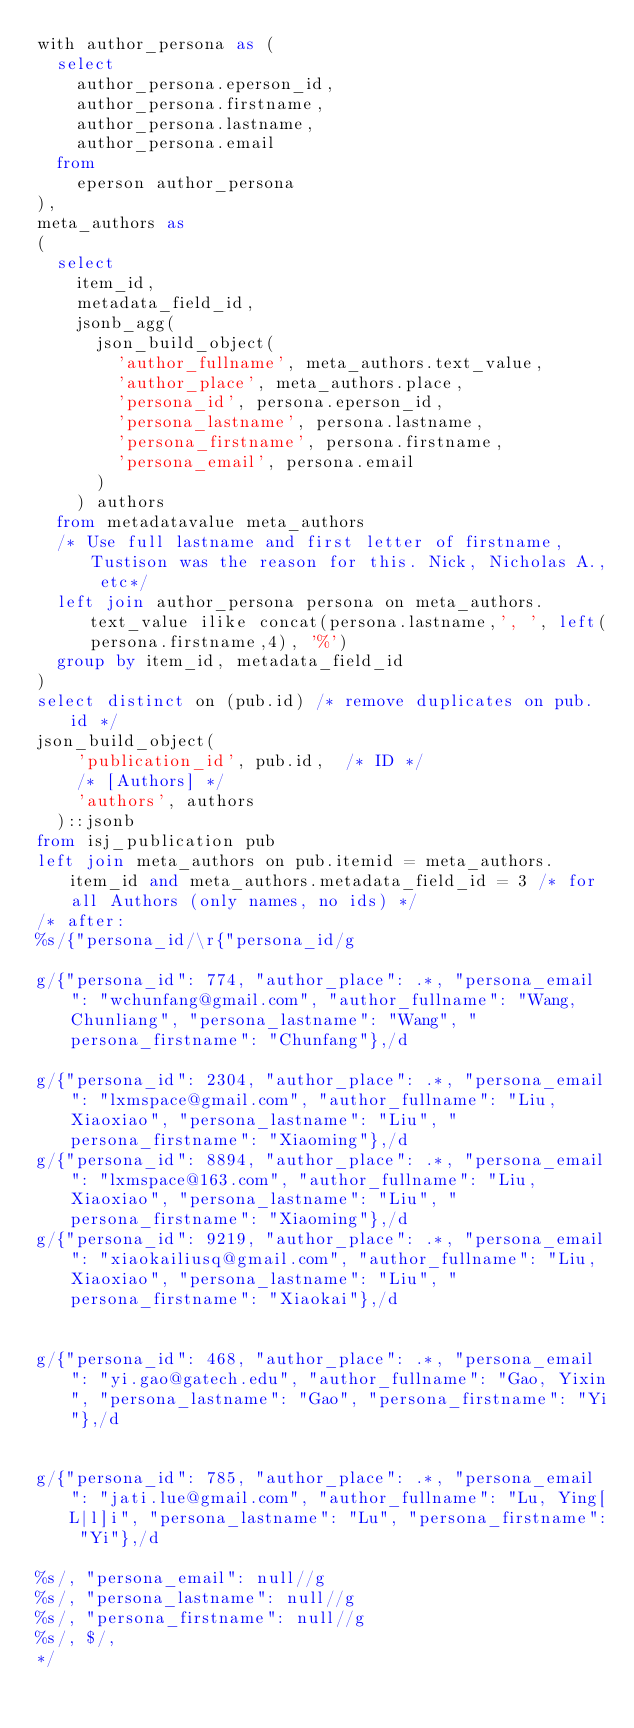Convert code to text. <code><loc_0><loc_0><loc_500><loc_500><_SQL_>with author_persona as (
  select
    author_persona.eperson_id,
    author_persona.firstname,
    author_persona.lastname,
    author_persona.email
  from
    eperson author_persona
),
meta_authors as
(
  select
	item_id,
	metadata_field_id,
	jsonb_agg(
	  json_build_object(
		'author_fullname', meta_authors.text_value,
		'author_place', meta_authors.place,
		'persona_id', persona.eperson_id,
		'persona_lastname', persona.lastname,
		'persona_firstname', persona.firstname,
		'persona_email', persona.email
	  )
	) authors
  from metadatavalue meta_authors
  /* Use full lastname and first letter of firstname, Tustison was the reason for this. Nick, Nicholas A., etc*/
  left join author_persona persona on meta_authors.text_value ilike concat(persona.lastname,', ', left(persona.firstname,4), '%')
  group by item_id, metadata_field_id
)
select distinct on (pub.id) /* remove duplicates on pub.id */
json_build_object(
	'publication_id', pub.id,  /* ID */
	/* [Authors] */
	'authors', authors
  )::jsonb
from isj_publication pub
left join meta_authors on pub.itemid = meta_authors.item_id and meta_authors.metadata_field_id = 3 /* for all Authors (only names, no ids) */
/* after:
%s/{"persona_id/\r{"persona_id/g

g/{"persona_id": 774, "author_place": .*, "persona_email": "wchunfang@gmail.com", "author_fullname": "Wang, Chunliang", "persona_lastname": "Wang", "persona_firstname": "Chunfang"},/d

g/{"persona_id": 2304, "author_place": .*, "persona_email": "lxmspace@gmail.com", "author_fullname": "Liu, Xiaoxiao", "persona_lastname": "Liu", "persona_firstname": "Xiaoming"},/d
g/{"persona_id": 8894, "author_place": .*, "persona_email": "lxmspace@163.com", "author_fullname": "Liu, Xiaoxiao", "persona_lastname": "Liu", "persona_firstname": "Xiaoming"},/d
g/{"persona_id": 9219, "author_place": .*, "persona_email": "xiaokailiusq@gmail.com", "author_fullname": "Liu, Xiaoxiao", "persona_lastname": "Liu", "persona_firstname": "Xiaokai"},/d


g/{"persona_id": 468, "author_place": .*, "persona_email": "yi.gao@gatech.edu", "author_fullname": "Gao, Yixin", "persona_lastname": "Gao", "persona_firstname": "Yi"},/d


g/{"persona_id": 785, "author_place": .*, "persona_email": "jati.lue@gmail.com", "author_fullname": "Lu, Ying[L|l]i", "persona_lastname": "Lu", "persona_firstname": "Yi"},/d

%s/, "persona_email": null//g
%s/, "persona_lastname": null//g
%s/, "persona_firstname": null//g
%s/, $/,
*/
</code> 